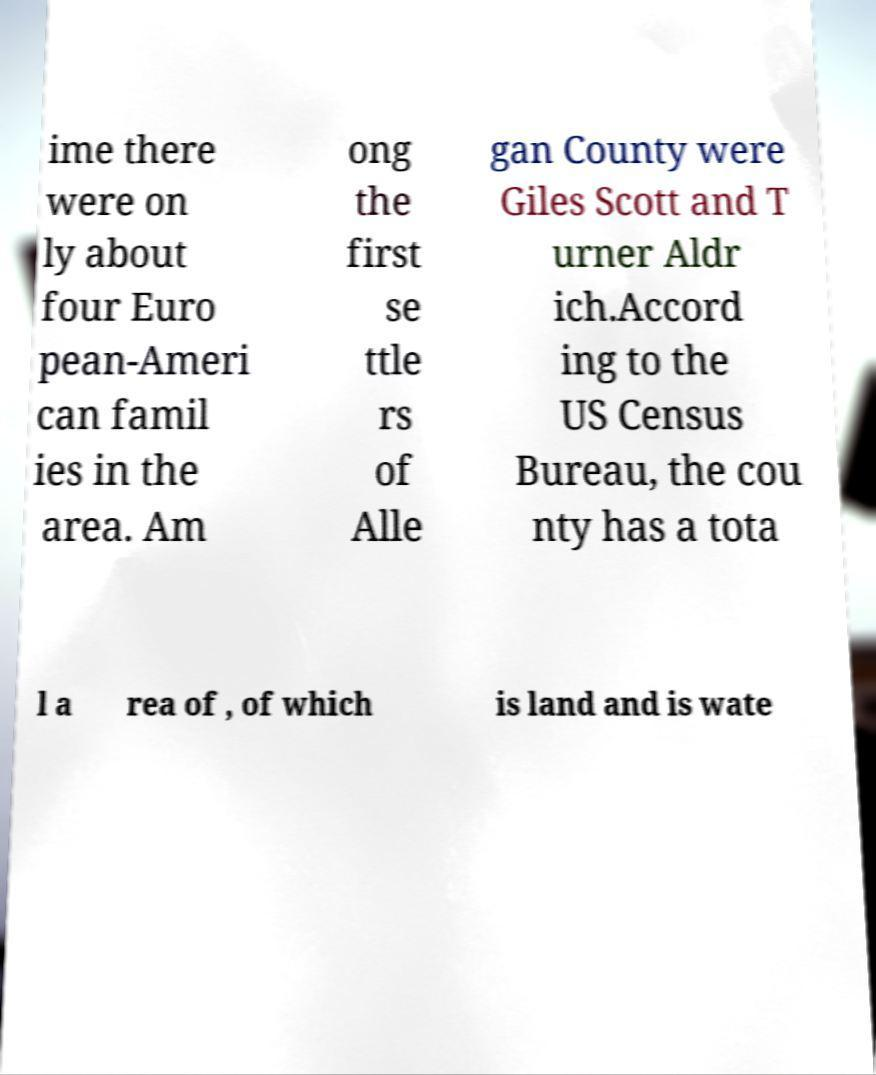Can you accurately transcribe the text from the provided image for me? ime there were on ly about four Euro pean-Ameri can famil ies in the area. Am ong the first se ttle rs of Alle gan County were Giles Scott and T urner Aldr ich.Accord ing to the US Census Bureau, the cou nty has a tota l a rea of , of which is land and is wate 